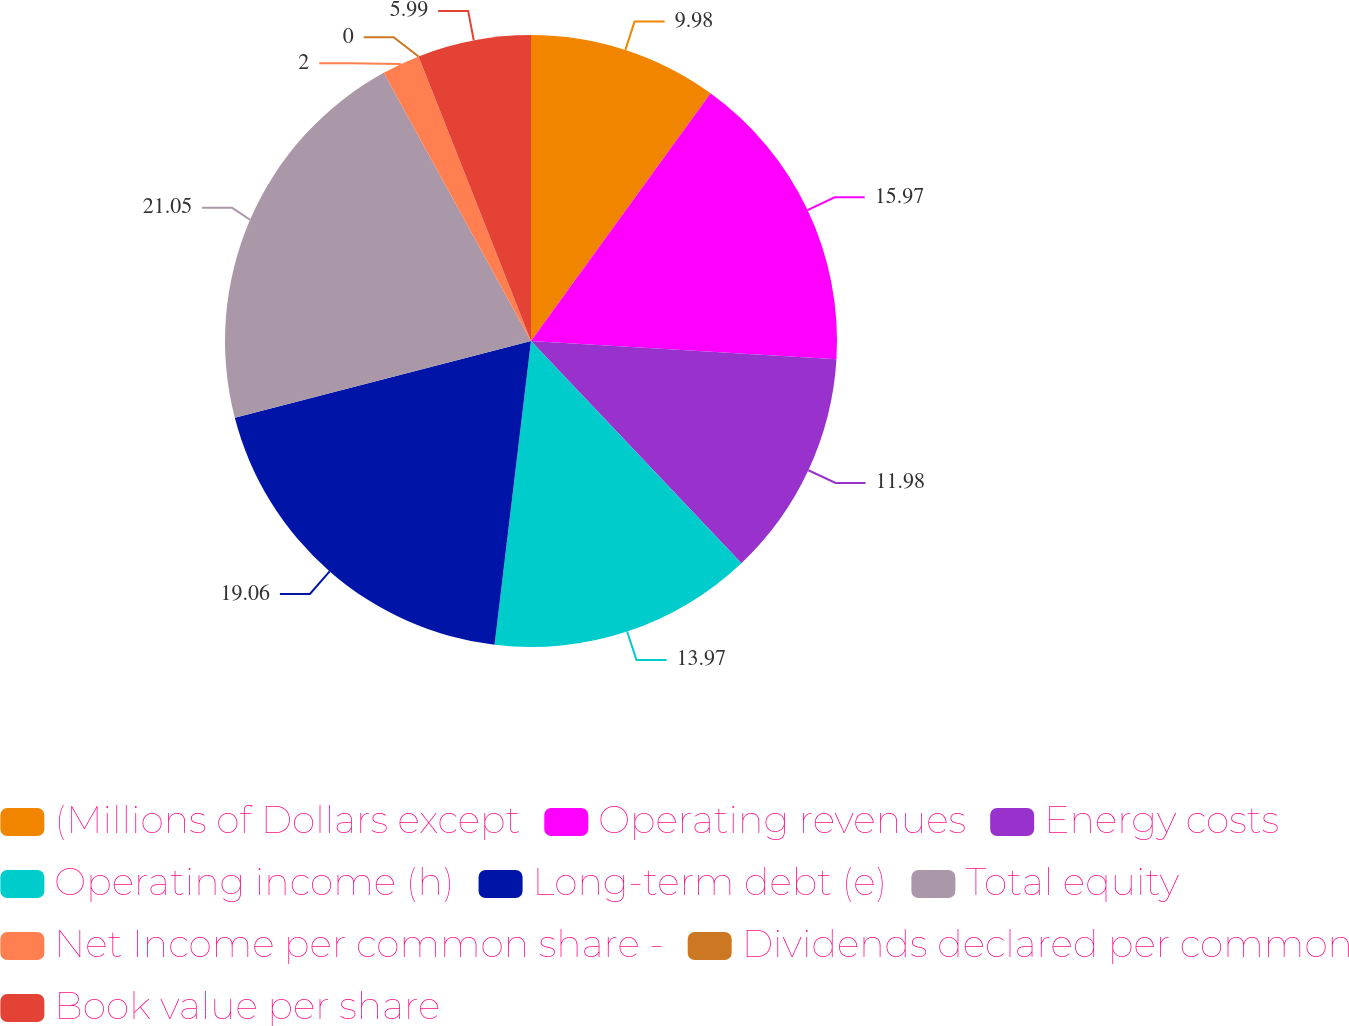Convert chart to OTSL. <chart><loc_0><loc_0><loc_500><loc_500><pie_chart><fcel>(Millions of Dollars except<fcel>Operating revenues<fcel>Energy costs<fcel>Operating income (h)<fcel>Long-term debt (e)<fcel>Total equity<fcel>Net Income per common share -<fcel>Dividends declared per common<fcel>Book value per share<nl><fcel>9.98%<fcel>15.97%<fcel>11.98%<fcel>13.97%<fcel>19.06%<fcel>21.05%<fcel>2.0%<fcel>0.0%<fcel>5.99%<nl></chart> 